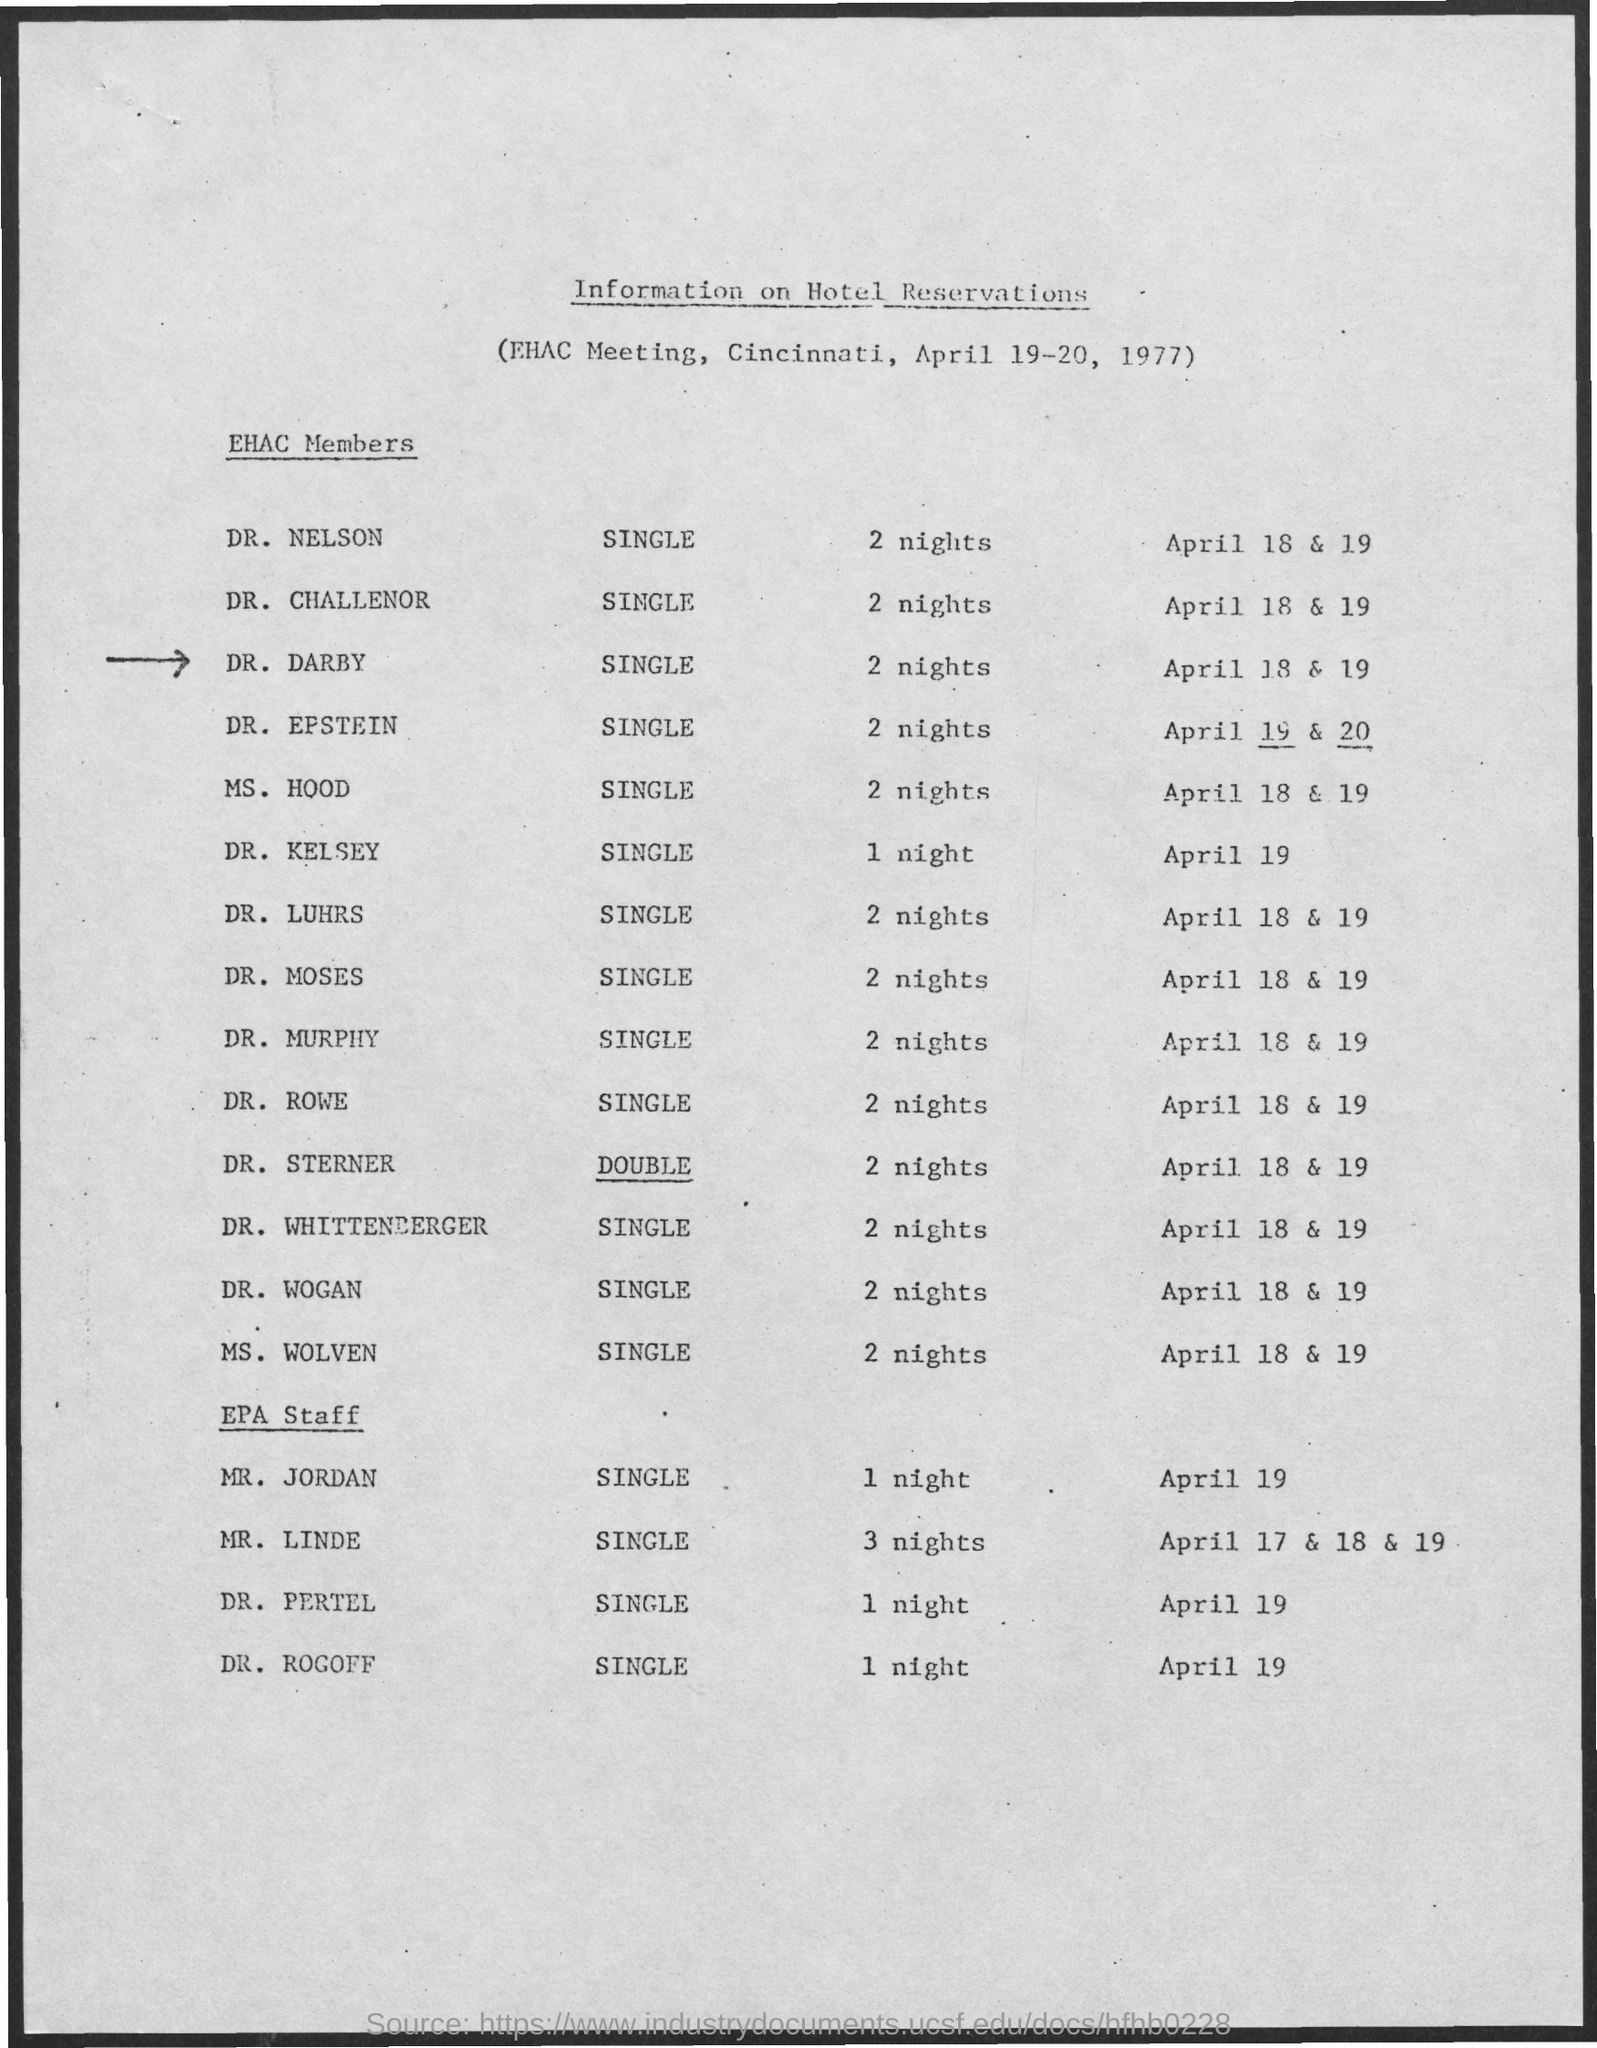When is the EHAC Meeting, Cincinnati held?
Your response must be concise. April 19-20, 1977. What information is shared in this document?
Give a very brief answer. Information on Hotel Reservations. How many nights of the hotel reservation is booked for DR. DARBY?
Make the answer very short. 2 nights. On which date, hotel reservation is done for DR. KELSEY?
Ensure brevity in your answer.  April 19. On which dates, hotel reservation is done for MR. LINDE?
Provide a short and direct response. April 17 & 18 & 19. 